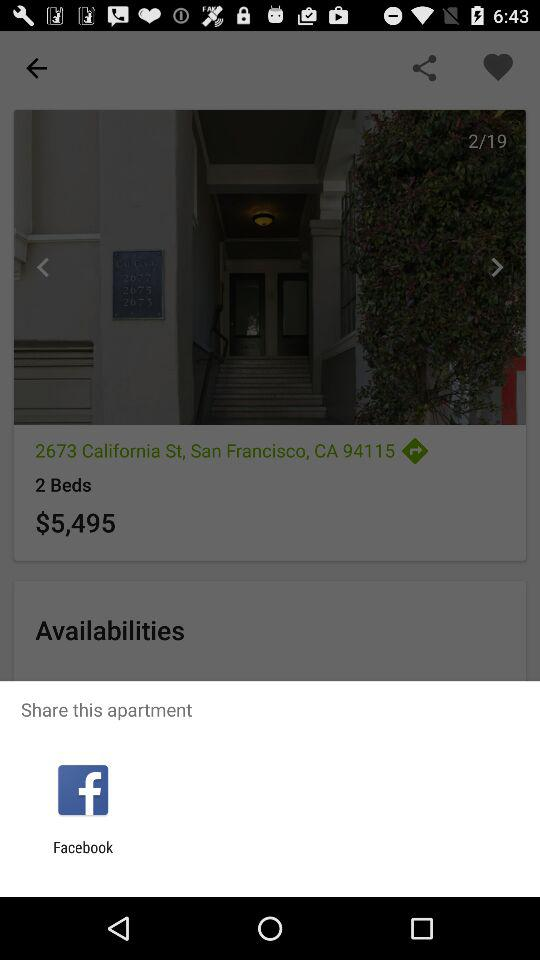What is the number of bed? The number of bed is 2. 